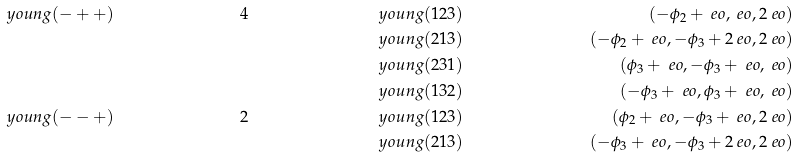<formula> <loc_0><loc_0><loc_500><loc_500>\ y o u n g ( - + + ) & & 4 & & \ y o u n g ( 1 2 3 ) & & ( - \phi _ { 2 } + \ e o , \ e o , 2 \ e o ) \\ & & & & \ y o u n g ( 2 1 3 ) & & ( - \phi _ { 2 } + \ e o , - \phi _ { 3 } + 2 \ e o , 2 \ e o ) \\ & & & & \ y o u n g ( 2 3 1 ) & & ( \phi _ { 3 } + \ e o , - \phi _ { 3 } + \ e o , \ e o ) \\ & & & & \ y o u n g ( 1 3 2 ) & & ( - \phi _ { 3 } + \ e o , \phi _ { 3 } + \ e o , \ e o ) \\ \ y o u n g ( - - + ) & & 2 & & \ y o u n g ( 1 2 3 ) & & ( \phi _ { 2 } + \ e o , - \phi _ { 3 } + \ e o , 2 \ e o ) \\ & & & & \ y o u n g ( 2 1 3 ) & & ( - \phi _ { 3 } + \ e o , - \phi _ { 3 } + 2 \ e o , 2 \ e o )</formula> 